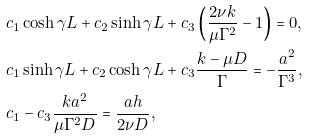<formula> <loc_0><loc_0><loc_500><loc_500>& c _ { 1 } \cosh { \gamma L } + c _ { 2 } \sinh { \gamma L } + c _ { 3 } \left ( \frac { 2 \nu k } { \mu \Gamma ^ { 2 } } - 1 \right ) = 0 , \\ & c _ { 1 } \sinh { \gamma L } + c _ { 2 } \cosh { \gamma L } + c _ { 3 } \frac { k - \mu D } { \Gamma } = - \frac { a ^ { 2 } } { \Gamma ^ { 3 } } , \\ & c _ { 1 } - c _ { 3 } \frac { k a ^ { 2 } } { \mu \Gamma ^ { 2 } D } = \frac { a h } { 2 \nu D } ,</formula> 